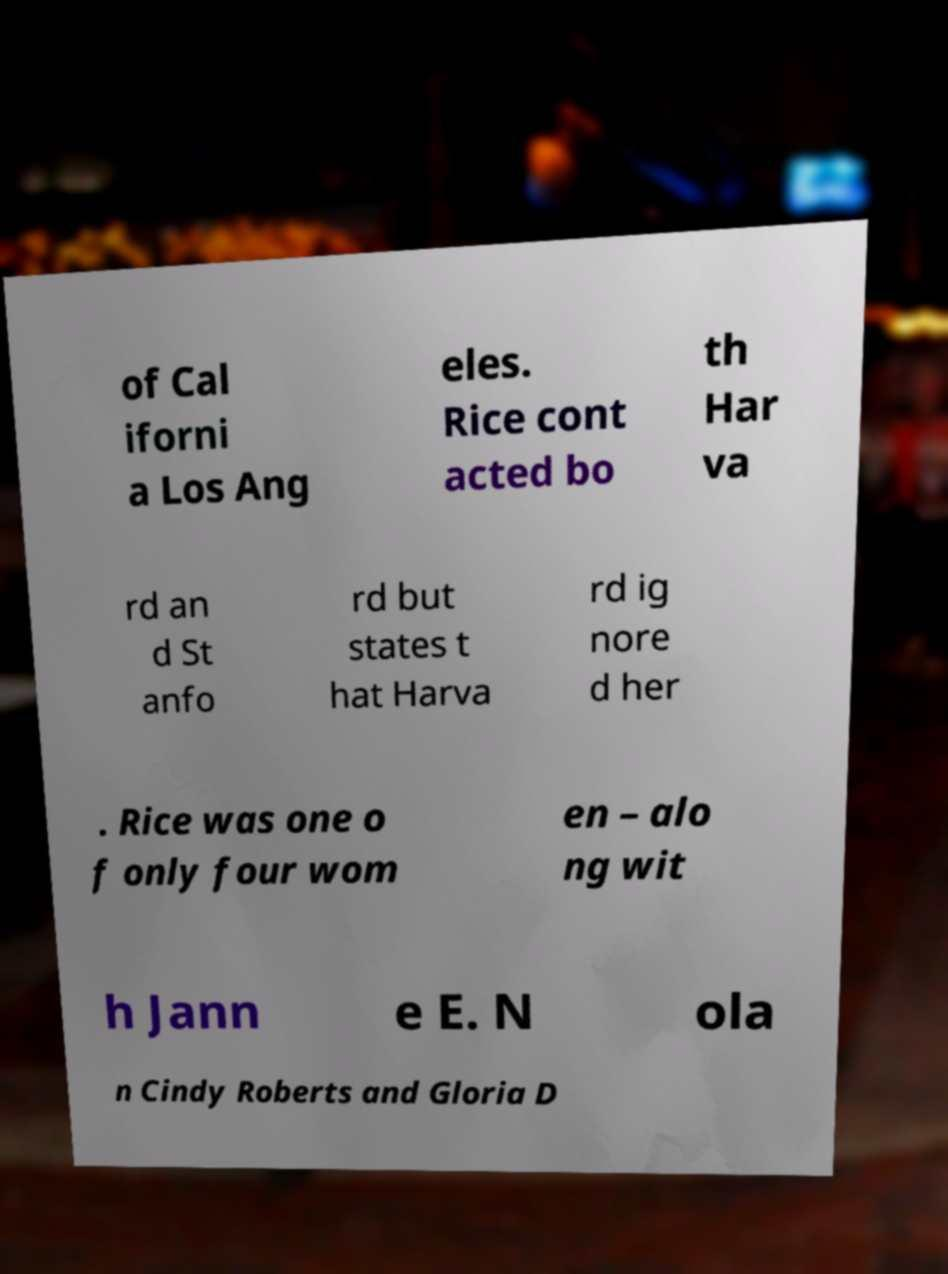Can you accurately transcribe the text from the provided image for me? of Cal iforni a Los Ang eles. Rice cont acted bo th Har va rd an d St anfo rd but states t hat Harva rd ig nore d her . Rice was one o f only four wom en – alo ng wit h Jann e E. N ola n Cindy Roberts and Gloria D 